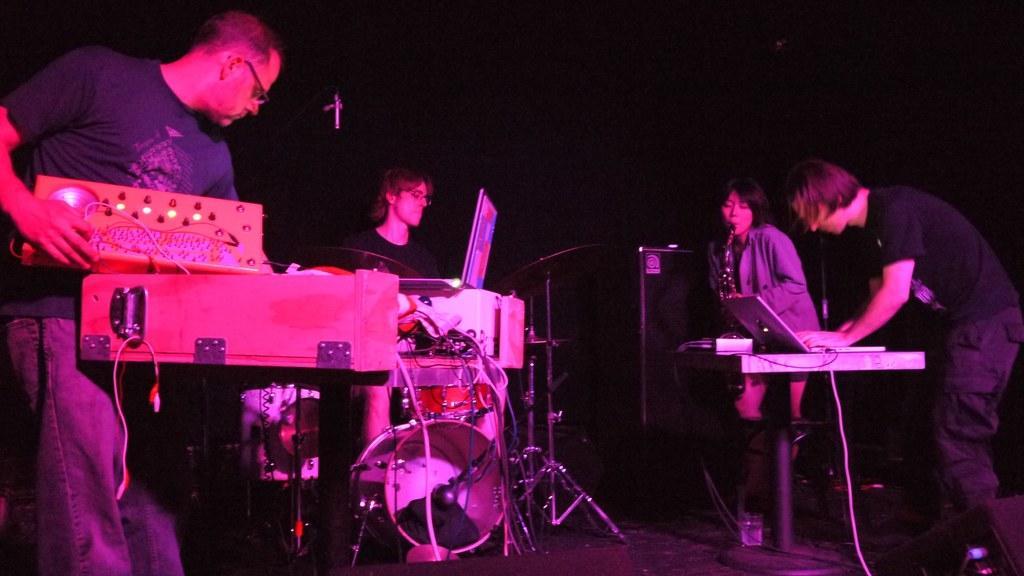Could you give a brief overview of what you see in this image? In this image there are some people who are standing and there are some musical instruments like drums, and there are two laptops and some wires and one woman is holding a musical instrument and playing. 